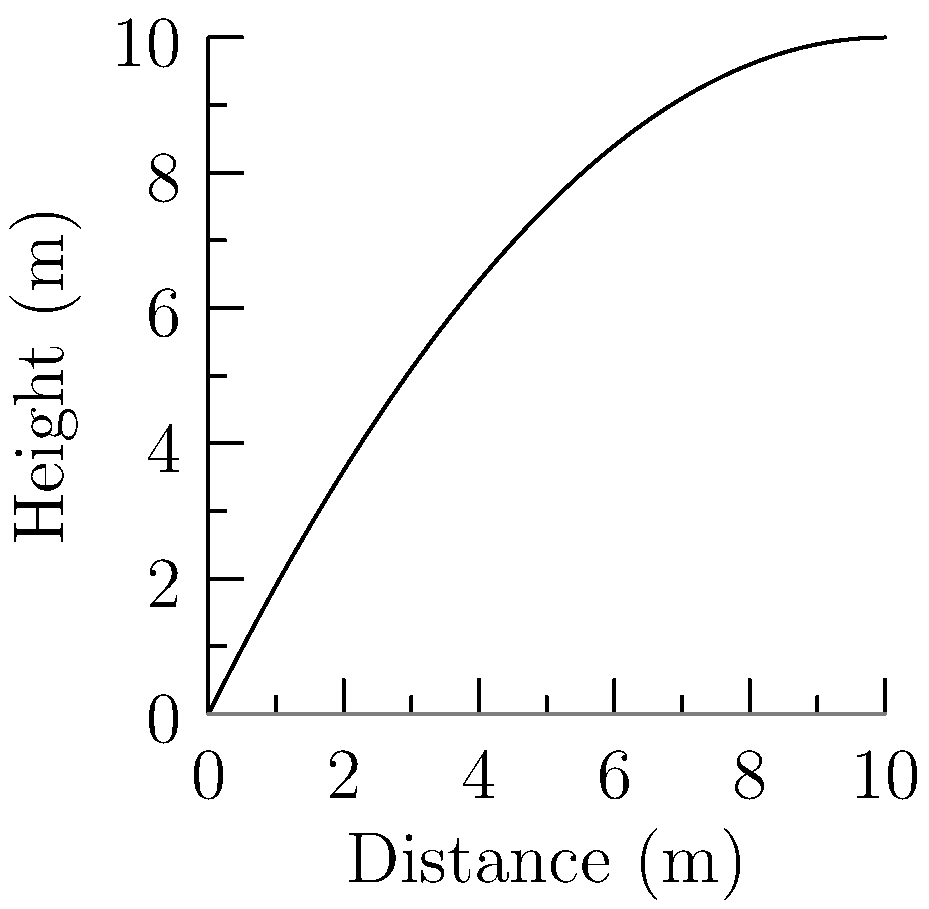During a snatch lift, the trajectory of a weightlifting bar can be modeled by the function $h(x) = 2x - 0.1x^2$, where $h$ is the height in meters and $x$ is the horizontal distance in meters. If Julio Cedeño performs a snatch lift and the bar travels a total horizontal distance of 10 meters, what is the maximum height reached by the bar during the lift? To find the maximum height of the trajectory, we need to follow these steps:

1) The function describing the trajectory is $h(x) = 2x - 0.1x^2$.

2) To find the maximum point, we need to find where the derivative of this function equals zero:
   
   $h'(x) = 2 - 0.2x$
   
   Set this equal to zero: $2 - 0.2x = 0$

3) Solve for x:
   
   $0.2x = 2$
   $x = 10$

4) This x-value represents the horizontal distance at which the maximum height occurs.

5) To find the maximum height, we plug this x-value back into our original function:

   $h(10) = 2(10) - 0.1(10)^2$
          $= 20 - 0.1(100)$
          $= 20 - 10$
          $= 10$

Therefore, the maximum height reached by the bar during the lift is 10 meters.
Answer: 10 meters 